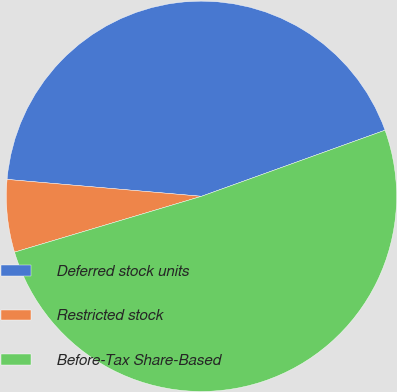Convert chart. <chart><loc_0><loc_0><loc_500><loc_500><pie_chart><fcel>Deferred stock units<fcel>Restricted stock<fcel>Before-Tax Share-Based<nl><fcel>43.12%<fcel>6.0%<fcel>50.88%<nl></chart> 